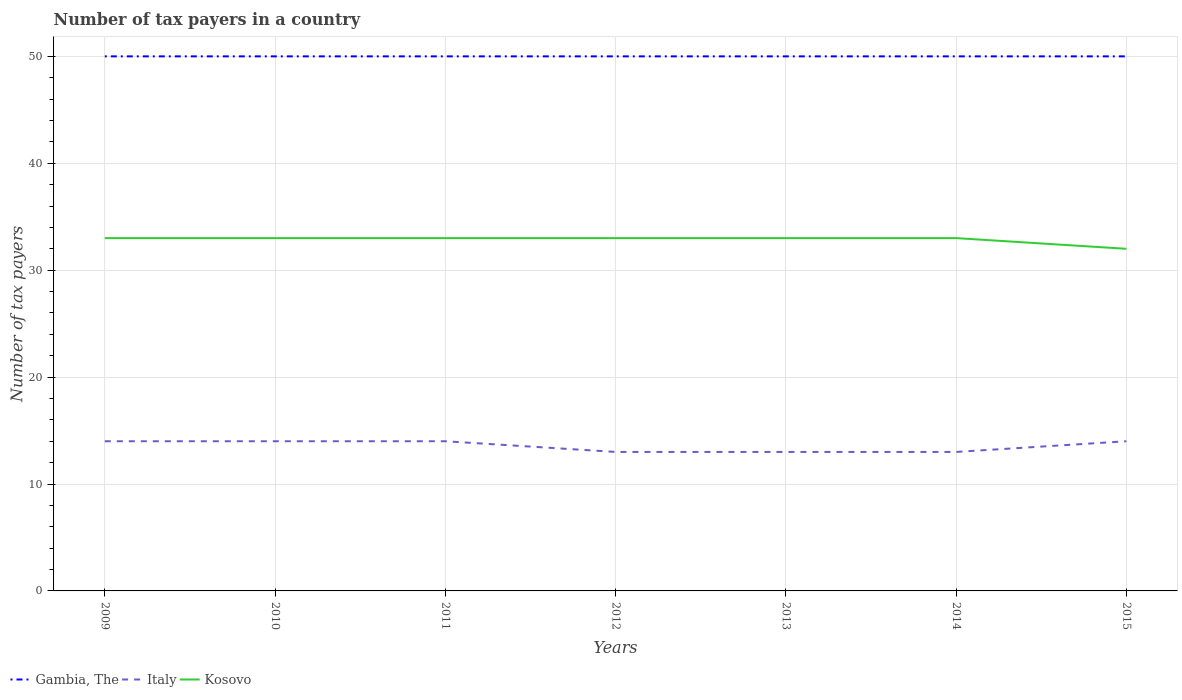How many different coloured lines are there?
Provide a short and direct response. 3. Is the number of lines equal to the number of legend labels?
Offer a terse response. Yes. Across all years, what is the maximum number of tax payers in in Italy?
Your answer should be compact. 13. In which year was the number of tax payers in in Italy maximum?
Keep it short and to the point. 2012. What is the total number of tax payers in in Gambia, The in the graph?
Your response must be concise. 0. What is the difference between the highest and the second highest number of tax payers in in Kosovo?
Your answer should be compact. 1. What is the difference between the highest and the lowest number of tax payers in in Italy?
Provide a succinct answer. 4. Is the number of tax payers in in Kosovo strictly greater than the number of tax payers in in Italy over the years?
Provide a succinct answer. No. Are the values on the major ticks of Y-axis written in scientific E-notation?
Give a very brief answer. No. Does the graph contain any zero values?
Provide a short and direct response. No. Where does the legend appear in the graph?
Provide a short and direct response. Bottom left. How many legend labels are there?
Your answer should be very brief. 3. What is the title of the graph?
Ensure brevity in your answer.  Number of tax payers in a country. Does "Sri Lanka" appear as one of the legend labels in the graph?
Your response must be concise. No. What is the label or title of the Y-axis?
Make the answer very short. Number of tax payers. What is the Number of tax payers of Gambia, The in 2010?
Your response must be concise. 50. What is the Number of tax payers of Italy in 2010?
Provide a short and direct response. 14. What is the Number of tax payers in Kosovo in 2010?
Keep it short and to the point. 33. What is the Number of tax payers of Italy in 2011?
Your answer should be very brief. 14. What is the Number of tax payers of Kosovo in 2011?
Ensure brevity in your answer.  33. What is the Number of tax payers of Italy in 2012?
Keep it short and to the point. 13. What is the Number of tax payers of Kosovo in 2012?
Offer a very short reply. 33. What is the Number of tax payers in Gambia, The in 2013?
Give a very brief answer. 50. What is the Number of tax payers of Kosovo in 2013?
Your answer should be compact. 33. What is the Number of tax payers of Italy in 2014?
Provide a succinct answer. 13. What is the Number of tax payers in Kosovo in 2014?
Ensure brevity in your answer.  33. What is the Number of tax payers in Gambia, The in 2015?
Give a very brief answer. 50. What is the Number of tax payers in Kosovo in 2015?
Keep it short and to the point. 32. Across all years, what is the maximum Number of tax payers of Gambia, The?
Give a very brief answer. 50. Across all years, what is the maximum Number of tax payers of Kosovo?
Your answer should be compact. 33. Across all years, what is the minimum Number of tax payers in Italy?
Provide a succinct answer. 13. Across all years, what is the minimum Number of tax payers of Kosovo?
Ensure brevity in your answer.  32. What is the total Number of tax payers of Gambia, The in the graph?
Keep it short and to the point. 350. What is the total Number of tax payers in Kosovo in the graph?
Your answer should be compact. 230. What is the difference between the Number of tax payers of Italy in 2009 and that in 2011?
Offer a very short reply. 0. What is the difference between the Number of tax payers of Kosovo in 2009 and that in 2011?
Your answer should be compact. 0. What is the difference between the Number of tax payers of Gambia, The in 2009 and that in 2012?
Offer a very short reply. 0. What is the difference between the Number of tax payers in Italy in 2009 and that in 2012?
Offer a very short reply. 1. What is the difference between the Number of tax payers of Kosovo in 2009 and that in 2012?
Your response must be concise. 0. What is the difference between the Number of tax payers in Gambia, The in 2009 and that in 2013?
Provide a succinct answer. 0. What is the difference between the Number of tax payers of Gambia, The in 2009 and that in 2014?
Ensure brevity in your answer.  0. What is the difference between the Number of tax payers of Italy in 2009 and that in 2014?
Your answer should be compact. 1. What is the difference between the Number of tax payers in Kosovo in 2009 and that in 2014?
Provide a short and direct response. 0. What is the difference between the Number of tax payers of Gambia, The in 2009 and that in 2015?
Offer a very short reply. 0. What is the difference between the Number of tax payers of Italy in 2009 and that in 2015?
Offer a terse response. 0. What is the difference between the Number of tax payers in Kosovo in 2009 and that in 2015?
Provide a short and direct response. 1. What is the difference between the Number of tax payers in Italy in 2010 and that in 2011?
Keep it short and to the point. 0. What is the difference between the Number of tax payers in Gambia, The in 2010 and that in 2012?
Make the answer very short. 0. What is the difference between the Number of tax payers of Gambia, The in 2010 and that in 2013?
Make the answer very short. 0. What is the difference between the Number of tax payers in Kosovo in 2010 and that in 2013?
Offer a terse response. 0. What is the difference between the Number of tax payers of Italy in 2010 and that in 2015?
Keep it short and to the point. 0. What is the difference between the Number of tax payers of Kosovo in 2010 and that in 2015?
Offer a very short reply. 1. What is the difference between the Number of tax payers of Italy in 2011 and that in 2012?
Your answer should be compact. 1. What is the difference between the Number of tax payers in Gambia, The in 2011 and that in 2013?
Keep it short and to the point. 0. What is the difference between the Number of tax payers in Italy in 2011 and that in 2013?
Your answer should be compact. 1. What is the difference between the Number of tax payers in Gambia, The in 2011 and that in 2015?
Keep it short and to the point. 0. What is the difference between the Number of tax payers in Kosovo in 2011 and that in 2015?
Ensure brevity in your answer.  1. What is the difference between the Number of tax payers in Italy in 2012 and that in 2013?
Give a very brief answer. 0. What is the difference between the Number of tax payers in Kosovo in 2012 and that in 2013?
Offer a very short reply. 0. What is the difference between the Number of tax payers of Italy in 2012 and that in 2014?
Provide a succinct answer. 0. What is the difference between the Number of tax payers of Kosovo in 2012 and that in 2014?
Keep it short and to the point. 0. What is the difference between the Number of tax payers in Gambia, The in 2013 and that in 2014?
Ensure brevity in your answer.  0. What is the difference between the Number of tax payers of Kosovo in 2013 and that in 2014?
Offer a very short reply. 0. What is the difference between the Number of tax payers of Kosovo in 2013 and that in 2015?
Keep it short and to the point. 1. What is the difference between the Number of tax payers of Kosovo in 2014 and that in 2015?
Make the answer very short. 1. What is the difference between the Number of tax payers of Gambia, The in 2009 and the Number of tax payers of Italy in 2010?
Make the answer very short. 36. What is the difference between the Number of tax payers of Gambia, The in 2009 and the Number of tax payers of Kosovo in 2010?
Provide a succinct answer. 17. What is the difference between the Number of tax payers of Italy in 2009 and the Number of tax payers of Kosovo in 2011?
Provide a short and direct response. -19. What is the difference between the Number of tax payers of Italy in 2009 and the Number of tax payers of Kosovo in 2012?
Offer a very short reply. -19. What is the difference between the Number of tax payers of Gambia, The in 2009 and the Number of tax payers of Kosovo in 2013?
Keep it short and to the point. 17. What is the difference between the Number of tax payers of Italy in 2009 and the Number of tax payers of Kosovo in 2013?
Ensure brevity in your answer.  -19. What is the difference between the Number of tax payers in Gambia, The in 2009 and the Number of tax payers in Italy in 2014?
Ensure brevity in your answer.  37. What is the difference between the Number of tax payers of Gambia, The in 2009 and the Number of tax payers of Kosovo in 2014?
Provide a succinct answer. 17. What is the difference between the Number of tax payers in Italy in 2009 and the Number of tax payers in Kosovo in 2015?
Provide a short and direct response. -18. What is the difference between the Number of tax payers in Gambia, The in 2010 and the Number of tax payers in Kosovo in 2011?
Your response must be concise. 17. What is the difference between the Number of tax payers of Italy in 2010 and the Number of tax payers of Kosovo in 2011?
Make the answer very short. -19. What is the difference between the Number of tax payers in Gambia, The in 2010 and the Number of tax payers in Kosovo in 2012?
Give a very brief answer. 17. What is the difference between the Number of tax payers of Gambia, The in 2010 and the Number of tax payers of Kosovo in 2013?
Your answer should be compact. 17. What is the difference between the Number of tax payers in Gambia, The in 2010 and the Number of tax payers in Kosovo in 2014?
Offer a very short reply. 17. What is the difference between the Number of tax payers in Gambia, The in 2010 and the Number of tax payers in Italy in 2015?
Your response must be concise. 36. What is the difference between the Number of tax payers of Gambia, The in 2010 and the Number of tax payers of Kosovo in 2015?
Offer a terse response. 18. What is the difference between the Number of tax payers in Italy in 2010 and the Number of tax payers in Kosovo in 2015?
Your response must be concise. -18. What is the difference between the Number of tax payers in Gambia, The in 2011 and the Number of tax payers in Italy in 2012?
Make the answer very short. 37. What is the difference between the Number of tax payers in Gambia, The in 2011 and the Number of tax payers in Kosovo in 2012?
Keep it short and to the point. 17. What is the difference between the Number of tax payers in Italy in 2011 and the Number of tax payers in Kosovo in 2012?
Make the answer very short. -19. What is the difference between the Number of tax payers of Gambia, The in 2011 and the Number of tax payers of Italy in 2013?
Ensure brevity in your answer.  37. What is the difference between the Number of tax payers of Italy in 2011 and the Number of tax payers of Kosovo in 2013?
Provide a short and direct response. -19. What is the difference between the Number of tax payers of Italy in 2011 and the Number of tax payers of Kosovo in 2014?
Offer a very short reply. -19. What is the difference between the Number of tax payers of Gambia, The in 2011 and the Number of tax payers of Italy in 2015?
Offer a very short reply. 36. What is the difference between the Number of tax payers in Gambia, The in 2011 and the Number of tax payers in Kosovo in 2015?
Your response must be concise. 18. What is the difference between the Number of tax payers in Gambia, The in 2012 and the Number of tax payers in Kosovo in 2013?
Offer a very short reply. 17. What is the difference between the Number of tax payers of Italy in 2012 and the Number of tax payers of Kosovo in 2013?
Offer a terse response. -20. What is the difference between the Number of tax payers in Gambia, The in 2012 and the Number of tax payers in Italy in 2014?
Offer a very short reply. 37. What is the difference between the Number of tax payers of Gambia, The in 2012 and the Number of tax payers of Kosovo in 2014?
Offer a very short reply. 17. What is the difference between the Number of tax payers in Gambia, The in 2012 and the Number of tax payers in Italy in 2015?
Provide a succinct answer. 36. What is the difference between the Number of tax payers in Gambia, The in 2013 and the Number of tax payers in Kosovo in 2014?
Your response must be concise. 17. What is the difference between the Number of tax payers of Italy in 2013 and the Number of tax payers of Kosovo in 2014?
Your answer should be very brief. -20. What is the difference between the Number of tax payers of Gambia, The in 2013 and the Number of tax payers of Italy in 2015?
Your answer should be compact. 36. What is the difference between the Number of tax payers in Gambia, The in 2013 and the Number of tax payers in Kosovo in 2015?
Provide a succinct answer. 18. What is the difference between the Number of tax payers in Gambia, The in 2014 and the Number of tax payers in Italy in 2015?
Make the answer very short. 36. What is the difference between the Number of tax payers of Gambia, The in 2014 and the Number of tax payers of Kosovo in 2015?
Ensure brevity in your answer.  18. What is the average Number of tax payers of Gambia, The per year?
Provide a succinct answer. 50. What is the average Number of tax payers of Italy per year?
Your response must be concise. 13.57. What is the average Number of tax payers in Kosovo per year?
Make the answer very short. 32.86. In the year 2009, what is the difference between the Number of tax payers of Italy and Number of tax payers of Kosovo?
Give a very brief answer. -19. In the year 2010, what is the difference between the Number of tax payers in Gambia, The and Number of tax payers in Kosovo?
Your answer should be compact. 17. In the year 2010, what is the difference between the Number of tax payers in Italy and Number of tax payers in Kosovo?
Provide a succinct answer. -19. In the year 2011, what is the difference between the Number of tax payers in Italy and Number of tax payers in Kosovo?
Provide a succinct answer. -19. In the year 2012, what is the difference between the Number of tax payers of Gambia, The and Number of tax payers of Italy?
Your answer should be very brief. 37. In the year 2012, what is the difference between the Number of tax payers in Gambia, The and Number of tax payers in Kosovo?
Your response must be concise. 17. In the year 2013, what is the difference between the Number of tax payers in Gambia, The and Number of tax payers in Italy?
Offer a very short reply. 37. In the year 2013, what is the difference between the Number of tax payers of Italy and Number of tax payers of Kosovo?
Offer a terse response. -20. In the year 2014, what is the difference between the Number of tax payers in Italy and Number of tax payers in Kosovo?
Offer a very short reply. -20. In the year 2015, what is the difference between the Number of tax payers in Gambia, The and Number of tax payers in Italy?
Give a very brief answer. 36. In the year 2015, what is the difference between the Number of tax payers of Italy and Number of tax payers of Kosovo?
Your answer should be very brief. -18. What is the ratio of the Number of tax payers of Italy in 2009 to that in 2010?
Your response must be concise. 1. What is the ratio of the Number of tax payers of Kosovo in 2009 to that in 2010?
Your response must be concise. 1. What is the ratio of the Number of tax payers in Gambia, The in 2009 to that in 2011?
Your answer should be compact. 1. What is the ratio of the Number of tax payers in Gambia, The in 2009 to that in 2012?
Provide a short and direct response. 1. What is the ratio of the Number of tax payers of Italy in 2009 to that in 2012?
Your response must be concise. 1.08. What is the ratio of the Number of tax payers of Kosovo in 2009 to that in 2012?
Your answer should be very brief. 1. What is the ratio of the Number of tax payers of Gambia, The in 2009 to that in 2014?
Ensure brevity in your answer.  1. What is the ratio of the Number of tax payers in Kosovo in 2009 to that in 2014?
Ensure brevity in your answer.  1. What is the ratio of the Number of tax payers in Gambia, The in 2009 to that in 2015?
Make the answer very short. 1. What is the ratio of the Number of tax payers in Kosovo in 2009 to that in 2015?
Give a very brief answer. 1.03. What is the ratio of the Number of tax payers of Italy in 2010 to that in 2011?
Keep it short and to the point. 1. What is the ratio of the Number of tax payers in Kosovo in 2010 to that in 2011?
Your response must be concise. 1. What is the ratio of the Number of tax payers in Italy in 2010 to that in 2012?
Keep it short and to the point. 1.08. What is the ratio of the Number of tax payers of Gambia, The in 2010 to that in 2013?
Give a very brief answer. 1. What is the ratio of the Number of tax payers of Kosovo in 2010 to that in 2013?
Provide a short and direct response. 1. What is the ratio of the Number of tax payers of Gambia, The in 2010 to that in 2014?
Make the answer very short. 1. What is the ratio of the Number of tax payers of Kosovo in 2010 to that in 2015?
Make the answer very short. 1.03. What is the ratio of the Number of tax payers of Gambia, The in 2011 to that in 2012?
Offer a terse response. 1. What is the ratio of the Number of tax payers of Italy in 2011 to that in 2012?
Offer a very short reply. 1.08. What is the ratio of the Number of tax payers of Gambia, The in 2011 to that in 2013?
Offer a terse response. 1. What is the ratio of the Number of tax payers in Italy in 2011 to that in 2014?
Provide a succinct answer. 1.08. What is the ratio of the Number of tax payers of Kosovo in 2011 to that in 2014?
Offer a terse response. 1. What is the ratio of the Number of tax payers of Gambia, The in 2011 to that in 2015?
Ensure brevity in your answer.  1. What is the ratio of the Number of tax payers in Kosovo in 2011 to that in 2015?
Offer a very short reply. 1.03. What is the ratio of the Number of tax payers in Kosovo in 2012 to that in 2013?
Your response must be concise. 1. What is the ratio of the Number of tax payers of Gambia, The in 2012 to that in 2014?
Make the answer very short. 1. What is the ratio of the Number of tax payers in Kosovo in 2012 to that in 2014?
Your answer should be very brief. 1. What is the ratio of the Number of tax payers of Gambia, The in 2012 to that in 2015?
Make the answer very short. 1. What is the ratio of the Number of tax payers in Italy in 2012 to that in 2015?
Offer a very short reply. 0.93. What is the ratio of the Number of tax payers of Kosovo in 2012 to that in 2015?
Make the answer very short. 1.03. What is the ratio of the Number of tax payers in Gambia, The in 2013 to that in 2014?
Make the answer very short. 1. What is the ratio of the Number of tax payers in Kosovo in 2013 to that in 2014?
Provide a short and direct response. 1. What is the ratio of the Number of tax payers in Italy in 2013 to that in 2015?
Offer a very short reply. 0.93. What is the ratio of the Number of tax payers in Kosovo in 2013 to that in 2015?
Provide a short and direct response. 1.03. What is the ratio of the Number of tax payers in Kosovo in 2014 to that in 2015?
Make the answer very short. 1.03. What is the difference between the highest and the second highest Number of tax payers of Italy?
Your answer should be very brief. 0. What is the difference between the highest and the second highest Number of tax payers of Kosovo?
Your answer should be very brief. 0. What is the difference between the highest and the lowest Number of tax payers of Kosovo?
Ensure brevity in your answer.  1. 